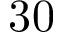<formula> <loc_0><loc_0><loc_500><loc_500>3 0</formula> 